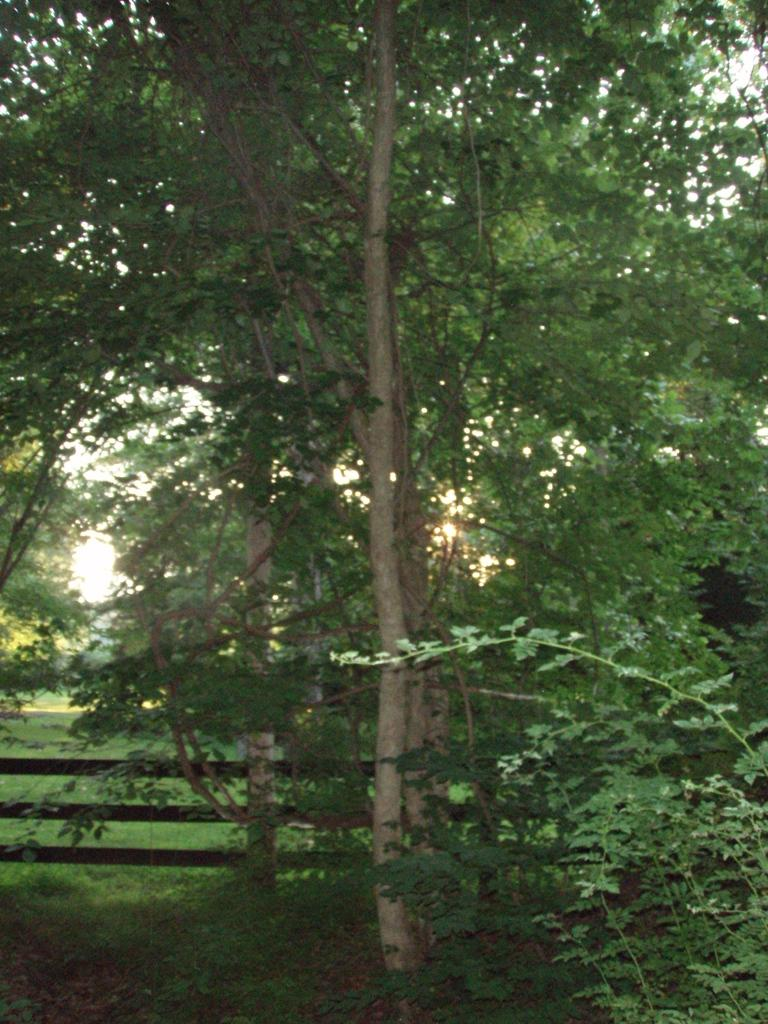What type of vegetation can be seen in the image? There are trees in the image. What type of barrier is present in the image? There is a wooden fence in the image. On what surface is the wooden fence placed? The wooden fence is on the surface of the grass. Where is the scarecrow sitting on the cushion in the image? There is no scarecrow or cushion present in the image. What type of prose is written on the wooden fence in the image? There is no prose written on the wooden fence in the image. 